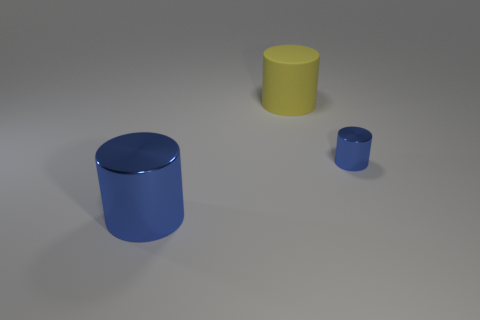Are there any metal cylinders of the same color as the large shiny object?
Ensure brevity in your answer.  Yes. Do the metallic object on the right side of the big blue cylinder and the large metal object have the same color?
Provide a short and direct response. Yes. What shape is the other object that is the same material as the tiny blue object?
Ensure brevity in your answer.  Cylinder. What material is the other large thing that is the same shape as the big blue metal object?
Keep it short and to the point. Rubber. There is a cylinder that is both in front of the yellow rubber cylinder and to the left of the small blue cylinder; what color is it?
Give a very brief answer. Blue. How many other objects are the same material as the big yellow object?
Your response must be concise. 0. Is the number of tiny purple metallic spheres less than the number of small blue objects?
Your answer should be very brief. Yes. Are the small cylinder and the big cylinder that is left of the big matte cylinder made of the same material?
Make the answer very short. Yes. There is a big object in front of the yellow cylinder; what shape is it?
Ensure brevity in your answer.  Cylinder. Are there any other things that have the same color as the big metal cylinder?
Provide a succinct answer. Yes. 